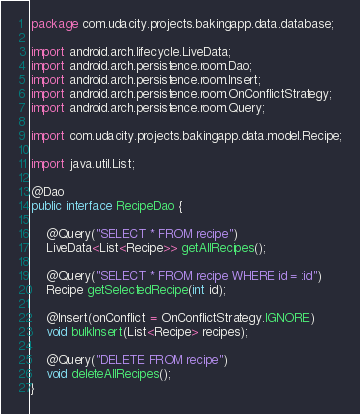<code> <loc_0><loc_0><loc_500><loc_500><_Java_>package com.udacity.projects.bakingapp.data.database;

import android.arch.lifecycle.LiveData;
import android.arch.persistence.room.Dao;
import android.arch.persistence.room.Insert;
import android.arch.persistence.room.OnConflictStrategy;
import android.arch.persistence.room.Query;

import com.udacity.projects.bakingapp.data.model.Recipe;

import java.util.List;

@Dao
public interface RecipeDao {

    @Query("SELECT * FROM recipe")
    LiveData<List<Recipe>> getAllRecipes();

    @Query("SELECT * FROM recipe WHERE id = :id")
    Recipe getSelectedRecipe(int id);

    @Insert(onConflict = OnConflictStrategy.IGNORE)
    void bulkInsert(List<Recipe> recipes);

    @Query("DELETE FROM recipe")
    void deleteAllRecipes();
}
</code> 